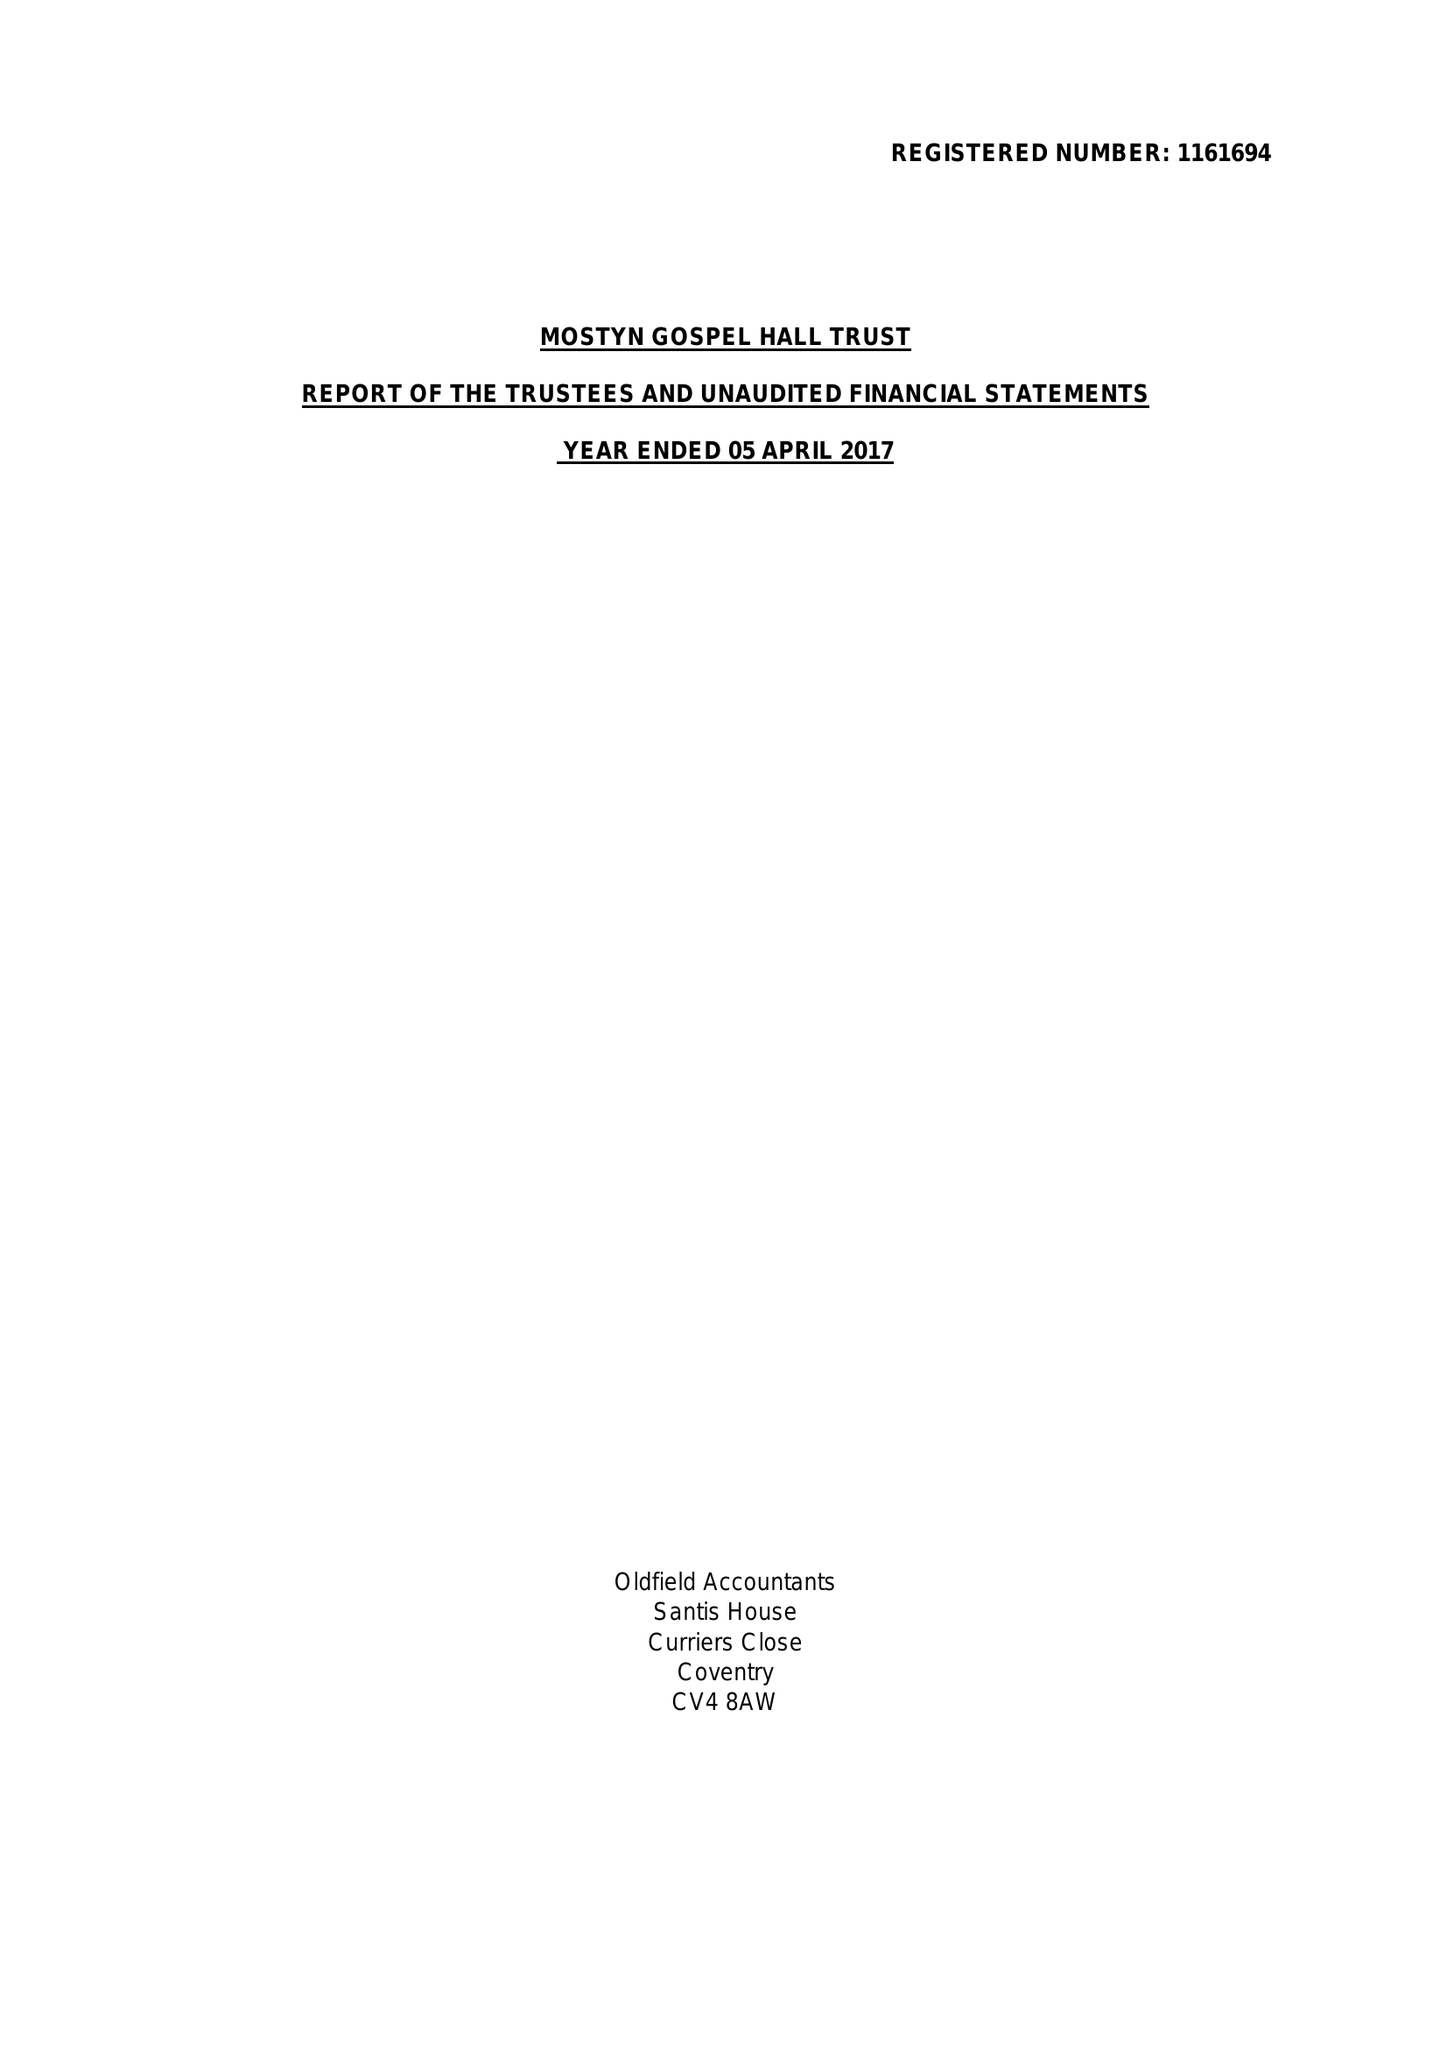What is the value for the address__street_line?
Answer the question using a single word or phrase. 190 STATION ROAD 